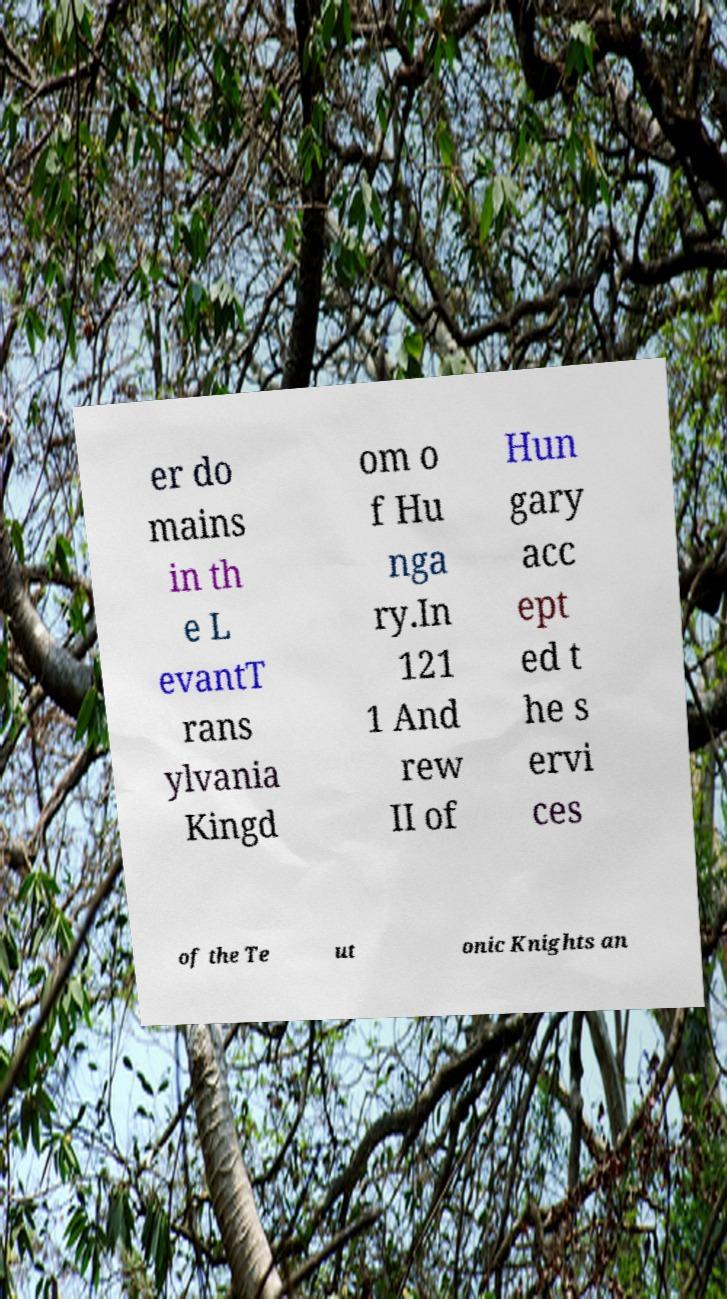Could you extract and type out the text from this image? er do mains in th e L evantT rans ylvania Kingd om o f Hu nga ry.In 121 1 And rew II of Hun gary acc ept ed t he s ervi ces of the Te ut onic Knights an 